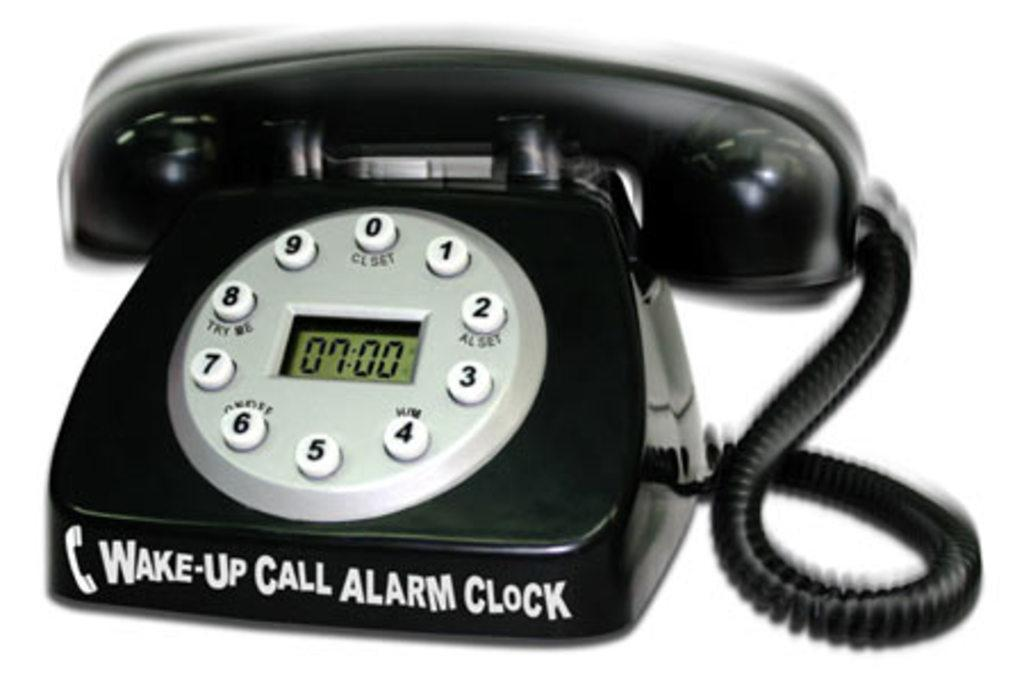Provide a one-sentence caption for the provided image. wake up call alarm clock written on a house phone. 